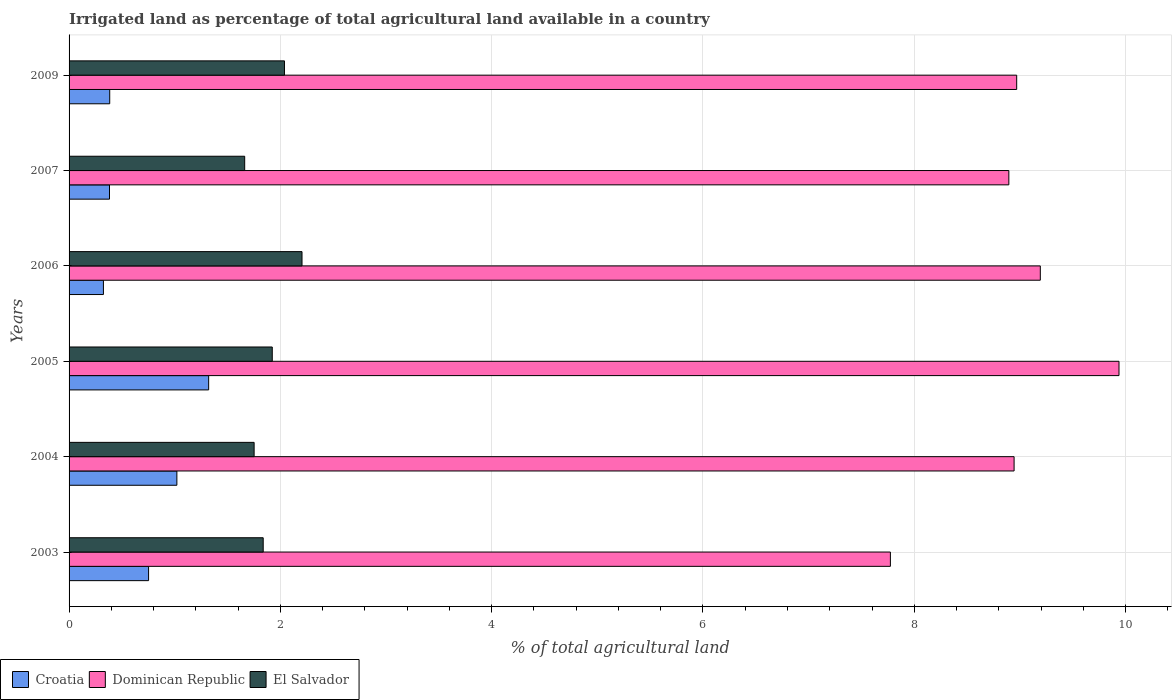How many different coloured bars are there?
Your answer should be very brief. 3. Are the number of bars on each tick of the Y-axis equal?
Provide a short and direct response. Yes. How many bars are there on the 2nd tick from the bottom?
Your answer should be compact. 3. In how many cases, is the number of bars for a given year not equal to the number of legend labels?
Make the answer very short. 0. What is the percentage of irrigated land in Croatia in 2005?
Ensure brevity in your answer.  1.32. Across all years, what is the maximum percentage of irrigated land in El Salvador?
Your answer should be very brief. 2.2. Across all years, what is the minimum percentage of irrigated land in El Salvador?
Keep it short and to the point. 1.66. In which year was the percentage of irrigated land in Dominican Republic maximum?
Make the answer very short. 2005. What is the total percentage of irrigated land in El Salvador in the graph?
Provide a succinct answer. 11.42. What is the difference between the percentage of irrigated land in Dominican Republic in 2005 and that in 2007?
Give a very brief answer. 1.04. What is the difference between the percentage of irrigated land in El Salvador in 2009 and the percentage of irrigated land in Croatia in 2003?
Your answer should be compact. 1.29. What is the average percentage of irrigated land in Dominican Republic per year?
Provide a succinct answer. 8.95. In the year 2006, what is the difference between the percentage of irrigated land in Croatia and percentage of irrigated land in El Salvador?
Keep it short and to the point. -1.88. What is the ratio of the percentage of irrigated land in El Salvador in 2004 to that in 2007?
Keep it short and to the point. 1.05. Is the percentage of irrigated land in Croatia in 2005 less than that in 2006?
Keep it short and to the point. No. Is the difference between the percentage of irrigated land in Croatia in 2003 and 2004 greater than the difference between the percentage of irrigated land in El Salvador in 2003 and 2004?
Your answer should be very brief. No. What is the difference between the highest and the second highest percentage of irrigated land in Dominican Republic?
Your answer should be compact. 0.74. What is the difference between the highest and the lowest percentage of irrigated land in El Salvador?
Your answer should be very brief. 0.54. In how many years, is the percentage of irrigated land in Dominican Republic greater than the average percentage of irrigated land in Dominican Republic taken over all years?
Ensure brevity in your answer.  3. What does the 3rd bar from the top in 2003 represents?
Keep it short and to the point. Croatia. What does the 2nd bar from the bottom in 2009 represents?
Provide a short and direct response. Dominican Republic. Is it the case that in every year, the sum of the percentage of irrigated land in El Salvador and percentage of irrigated land in Croatia is greater than the percentage of irrigated land in Dominican Republic?
Your response must be concise. No. How many bars are there?
Ensure brevity in your answer.  18. Are the values on the major ticks of X-axis written in scientific E-notation?
Your answer should be compact. No. How many legend labels are there?
Provide a succinct answer. 3. How are the legend labels stacked?
Give a very brief answer. Horizontal. What is the title of the graph?
Offer a terse response. Irrigated land as percentage of total agricultural land available in a country. What is the label or title of the X-axis?
Offer a very short reply. % of total agricultural land. What is the label or title of the Y-axis?
Keep it short and to the point. Years. What is the % of total agricultural land of Croatia in 2003?
Provide a short and direct response. 0.75. What is the % of total agricultural land in Dominican Republic in 2003?
Give a very brief answer. 7.77. What is the % of total agricultural land in El Salvador in 2003?
Make the answer very short. 1.84. What is the % of total agricultural land in Croatia in 2004?
Give a very brief answer. 1.02. What is the % of total agricultural land in Dominican Republic in 2004?
Provide a succinct answer. 8.94. What is the % of total agricultural land of El Salvador in 2004?
Ensure brevity in your answer.  1.75. What is the % of total agricultural land of Croatia in 2005?
Your response must be concise. 1.32. What is the % of total agricultural land in Dominican Republic in 2005?
Keep it short and to the point. 9.94. What is the % of total agricultural land of El Salvador in 2005?
Offer a terse response. 1.92. What is the % of total agricultural land of Croatia in 2006?
Make the answer very short. 0.33. What is the % of total agricultural land of Dominican Republic in 2006?
Give a very brief answer. 9.19. What is the % of total agricultural land of El Salvador in 2006?
Your answer should be very brief. 2.2. What is the % of total agricultural land of Croatia in 2007?
Provide a short and direct response. 0.38. What is the % of total agricultural land in Dominican Republic in 2007?
Make the answer very short. 8.9. What is the % of total agricultural land of El Salvador in 2007?
Offer a very short reply. 1.66. What is the % of total agricultural land of Croatia in 2009?
Give a very brief answer. 0.38. What is the % of total agricultural land in Dominican Republic in 2009?
Provide a succinct answer. 8.97. What is the % of total agricultural land of El Salvador in 2009?
Your answer should be compact. 2.04. Across all years, what is the maximum % of total agricultural land in Croatia?
Ensure brevity in your answer.  1.32. Across all years, what is the maximum % of total agricultural land of Dominican Republic?
Provide a succinct answer. 9.94. Across all years, what is the maximum % of total agricultural land of El Salvador?
Give a very brief answer. 2.2. Across all years, what is the minimum % of total agricultural land in Croatia?
Provide a succinct answer. 0.33. Across all years, what is the minimum % of total agricultural land of Dominican Republic?
Provide a short and direct response. 7.77. Across all years, what is the minimum % of total agricultural land of El Salvador?
Ensure brevity in your answer.  1.66. What is the total % of total agricultural land in Croatia in the graph?
Your answer should be very brief. 4.19. What is the total % of total agricultural land in Dominican Republic in the graph?
Provide a short and direct response. 53.72. What is the total % of total agricultural land of El Salvador in the graph?
Your answer should be very brief. 11.42. What is the difference between the % of total agricultural land in Croatia in 2003 and that in 2004?
Give a very brief answer. -0.27. What is the difference between the % of total agricultural land of Dominican Republic in 2003 and that in 2004?
Offer a terse response. -1.17. What is the difference between the % of total agricultural land of El Salvador in 2003 and that in 2004?
Offer a terse response. 0.09. What is the difference between the % of total agricultural land in Croatia in 2003 and that in 2005?
Offer a terse response. -0.57. What is the difference between the % of total agricultural land in Dominican Republic in 2003 and that in 2005?
Provide a short and direct response. -2.16. What is the difference between the % of total agricultural land of El Salvador in 2003 and that in 2005?
Provide a short and direct response. -0.09. What is the difference between the % of total agricultural land of Croatia in 2003 and that in 2006?
Give a very brief answer. 0.43. What is the difference between the % of total agricultural land of Dominican Republic in 2003 and that in 2006?
Provide a short and direct response. -1.42. What is the difference between the % of total agricultural land in El Salvador in 2003 and that in 2006?
Offer a very short reply. -0.37. What is the difference between the % of total agricultural land of Croatia in 2003 and that in 2007?
Your answer should be compact. 0.37. What is the difference between the % of total agricultural land in Dominican Republic in 2003 and that in 2007?
Your response must be concise. -1.12. What is the difference between the % of total agricultural land of El Salvador in 2003 and that in 2007?
Provide a succinct answer. 0.18. What is the difference between the % of total agricultural land of Croatia in 2003 and that in 2009?
Offer a very short reply. 0.37. What is the difference between the % of total agricultural land in Dominican Republic in 2003 and that in 2009?
Make the answer very short. -1.2. What is the difference between the % of total agricultural land in El Salvador in 2003 and that in 2009?
Give a very brief answer. -0.2. What is the difference between the % of total agricultural land of Croatia in 2004 and that in 2005?
Give a very brief answer. -0.3. What is the difference between the % of total agricultural land of Dominican Republic in 2004 and that in 2005?
Your answer should be compact. -0.99. What is the difference between the % of total agricultural land of El Salvador in 2004 and that in 2005?
Make the answer very short. -0.17. What is the difference between the % of total agricultural land of Croatia in 2004 and that in 2006?
Make the answer very short. 0.7. What is the difference between the % of total agricultural land in Dominican Republic in 2004 and that in 2006?
Provide a succinct answer. -0.25. What is the difference between the % of total agricultural land in El Salvador in 2004 and that in 2006?
Provide a short and direct response. -0.45. What is the difference between the % of total agricultural land in Croatia in 2004 and that in 2007?
Offer a very short reply. 0.64. What is the difference between the % of total agricultural land of Dominican Republic in 2004 and that in 2007?
Give a very brief answer. 0.05. What is the difference between the % of total agricultural land of El Salvador in 2004 and that in 2007?
Your answer should be very brief. 0.09. What is the difference between the % of total agricultural land in Croatia in 2004 and that in 2009?
Provide a succinct answer. 0.64. What is the difference between the % of total agricultural land of Dominican Republic in 2004 and that in 2009?
Your answer should be very brief. -0.02. What is the difference between the % of total agricultural land of El Salvador in 2004 and that in 2009?
Give a very brief answer. -0.29. What is the difference between the % of total agricultural land in Croatia in 2005 and that in 2006?
Provide a short and direct response. 1. What is the difference between the % of total agricultural land in Dominican Republic in 2005 and that in 2006?
Your response must be concise. 0.74. What is the difference between the % of total agricultural land in El Salvador in 2005 and that in 2006?
Give a very brief answer. -0.28. What is the difference between the % of total agricultural land of Croatia in 2005 and that in 2007?
Make the answer very short. 0.94. What is the difference between the % of total agricultural land of Dominican Republic in 2005 and that in 2007?
Give a very brief answer. 1.04. What is the difference between the % of total agricultural land of El Salvador in 2005 and that in 2007?
Your answer should be compact. 0.26. What is the difference between the % of total agricultural land of Croatia in 2005 and that in 2009?
Ensure brevity in your answer.  0.94. What is the difference between the % of total agricultural land in Dominican Republic in 2005 and that in 2009?
Offer a terse response. 0.97. What is the difference between the % of total agricultural land of El Salvador in 2005 and that in 2009?
Your answer should be very brief. -0.12. What is the difference between the % of total agricultural land of Croatia in 2006 and that in 2007?
Make the answer very short. -0.06. What is the difference between the % of total agricultural land in Dominican Republic in 2006 and that in 2007?
Your answer should be compact. 0.3. What is the difference between the % of total agricultural land in El Salvador in 2006 and that in 2007?
Your answer should be compact. 0.54. What is the difference between the % of total agricultural land in Croatia in 2006 and that in 2009?
Your response must be concise. -0.06. What is the difference between the % of total agricultural land of Dominican Republic in 2006 and that in 2009?
Keep it short and to the point. 0.22. What is the difference between the % of total agricultural land of El Salvador in 2006 and that in 2009?
Your answer should be very brief. 0.17. What is the difference between the % of total agricultural land in Croatia in 2007 and that in 2009?
Offer a terse response. -0. What is the difference between the % of total agricultural land of Dominican Republic in 2007 and that in 2009?
Your answer should be very brief. -0.07. What is the difference between the % of total agricultural land of El Salvador in 2007 and that in 2009?
Offer a terse response. -0.38. What is the difference between the % of total agricultural land in Croatia in 2003 and the % of total agricultural land in Dominican Republic in 2004?
Offer a terse response. -8.19. What is the difference between the % of total agricultural land of Croatia in 2003 and the % of total agricultural land of El Salvador in 2004?
Keep it short and to the point. -1. What is the difference between the % of total agricultural land of Dominican Republic in 2003 and the % of total agricultural land of El Salvador in 2004?
Offer a terse response. 6.02. What is the difference between the % of total agricultural land of Croatia in 2003 and the % of total agricultural land of Dominican Republic in 2005?
Your answer should be compact. -9.19. What is the difference between the % of total agricultural land of Croatia in 2003 and the % of total agricultural land of El Salvador in 2005?
Keep it short and to the point. -1.17. What is the difference between the % of total agricultural land of Dominican Republic in 2003 and the % of total agricultural land of El Salvador in 2005?
Give a very brief answer. 5.85. What is the difference between the % of total agricultural land of Croatia in 2003 and the % of total agricultural land of Dominican Republic in 2006?
Ensure brevity in your answer.  -8.44. What is the difference between the % of total agricultural land in Croatia in 2003 and the % of total agricultural land in El Salvador in 2006?
Your answer should be very brief. -1.45. What is the difference between the % of total agricultural land of Dominican Republic in 2003 and the % of total agricultural land of El Salvador in 2006?
Ensure brevity in your answer.  5.57. What is the difference between the % of total agricultural land in Croatia in 2003 and the % of total agricultural land in Dominican Republic in 2007?
Keep it short and to the point. -8.14. What is the difference between the % of total agricultural land of Croatia in 2003 and the % of total agricultural land of El Salvador in 2007?
Make the answer very short. -0.91. What is the difference between the % of total agricultural land in Dominican Republic in 2003 and the % of total agricultural land in El Salvador in 2007?
Make the answer very short. 6.11. What is the difference between the % of total agricultural land in Croatia in 2003 and the % of total agricultural land in Dominican Republic in 2009?
Offer a terse response. -8.22. What is the difference between the % of total agricultural land of Croatia in 2003 and the % of total agricultural land of El Salvador in 2009?
Your answer should be compact. -1.29. What is the difference between the % of total agricultural land of Dominican Republic in 2003 and the % of total agricultural land of El Salvador in 2009?
Your response must be concise. 5.74. What is the difference between the % of total agricultural land in Croatia in 2004 and the % of total agricultural land in Dominican Republic in 2005?
Your response must be concise. -8.92. What is the difference between the % of total agricultural land of Croatia in 2004 and the % of total agricultural land of El Salvador in 2005?
Offer a terse response. -0.9. What is the difference between the % of total agricultural land of Dominican Republic in 2004 and the % of total agricultural land of El Salvador in 2005?
Provide a short and direct response. 7.02. What is the difference between the % of total agricultural land in Croatia in 2004 and the % of total agricultural land in Dominican Republic in 2006?
Your response must be concise. -8.17. What is the difference between the % of total agricultural land in Croatia in 2004 and the % of total agricultural land in El Salvador in 2006?
Your answer should be compact. -1.18. What is the difference between the % of total agricultural land in Dominican Republic in 2004 and the % of total agricultural land in El Salvador in 2006?
Your answer should be very brief. 6.74. What is the difference between the % of total agricultural land in Croatia in 2004 and the % of total agricultural land in Dominican Republic in 2007?
Keep it short and to the point. -7.87. What is the difference between the % of total agricultural land of Croatia in 2004 and the % of total agricultural land of El Salvador in 2007?
Ensure brevity in your answer.  -0.64. What is the difference between the % of total agricultural land of Dominican Republic in 2004 and the % of total agricultural land of El Salvador in 2007?
Provide a short and direct response. 7.28. What is the difference between the % of total agricultural land of Croatia in 2004 and the % of total agricultural land of Dominican Republic in 2009?
Provide a succinct answer. -7.95. What is the difference between the % of total agricultural land in Croatia in 2004 and the % of total agricultural land in El Salvador in 2009?
Make the answer very short. -1.02. What is the difference between the % of total agricultural land in Dominican Republic in 2004 and the % of total agricultural land in El Salvador in 2009?
Provide a succinct answer. 6.91. What is the difference between the % of total agricultural land of Croatia in 2005 and the % of total agricultural land of Dominican Republic in 2006?
Offer a very short reply. -7.87. What is the difference between the % of total agricultural land in Croatia in 2005 and the % of total agricultural land in El Salvador in 2006?
Offer a terse response. -0.88. What is the difference between the % of total agricultural land of Dominican Republic in 2005 and the % of total agricultural land of El Salvador in 2006?
Provide a succinct answer. 7.73. What is the difference between the % of total agricultural land in Croatia in 2005 and the % of total agricultural land in Dominican Republic in 2007?
Your answer should be very brief. -7.57. What is the difference between the % of total agricultural land of Croatia in 2005 and the % of total agricultural land of El Salvador in 2007?
Your response must be concise. -0.34. What is the difference between the % of total agricultural land of Dominican Republic in 2005 and the % of total agricultural land of El Salvador in 2007?
Your answer should be compact. 8.28. What is the difference between the % of total agricultural land of Croatia in 2005 and the % of total agricultural land of Dominican Republic in 2009?
Ensure brevity in your answer.  -7.65. What is the difference between the % of total agricultural land of Croatia in 2005 and the % of total agricultural land of El Salvador in 2009?
Offer a terse response. -0.72. What is the difference between the % of total agricultural land in Dominican Republic in 2005 and the % of total agricultural land in El Salvador in 2009?
Give a very brief answer. 7.9. What is the difference between the % of total agricultural land of Croatia in 2006 and the % of total agricultural land of Dominican Republic in 2007?
Provide a succinct answer. -8.57. What is the difference between the % of total agricultural land in Croatia in 2006 and the % of total agricultural land in El Salvador in 2007?
Keep it short and to the point. -1.34. What is the difference between the % of total agricultural land of Dominican Republic in 2006 and the % of total agricultural land of El Salvador in 2007?
Keep it short and to the point. 7.53. What is the difference between the % of total agricultural land in Croatia in 2006 and the % of total agricultural land in Dominican Republic in 2009?
Keep it short and to the point. -8.64. What is the difference between the % of total agricultural land in Croatia in 2006 and the % of total agricultural land in El Salvador in 2009?
Ensure brevity in your answer.  -1.71. What is the difference between the % of total agricultural land of Dominican Republic in 2006 and the % of total agricultural land of El Salvador in 2009?
Make the answer very short. 7.15. What is the difference between the % of total agricultural land of Croatia in 2007 and the % of total agricultural land of Dominican Republic in 2009?
Ensure brevity in your answer.  -8.59. What is the difference between the % of total agricultural land in Croatia in 2007 and the % of total agricultural land in El Salvador in 2009?
Provide a short and direct response. -1.66. What is the difference between the % of total agricultural land in Dominican Republic in 2007 and the % of total agricultural land in El Salvador in 2009?
Your response must be concise. 6.86. What is the average % of total agricultural land in Croatia per year?
Provide a succinct answer. 0.7. What is the average % of total agricultural land in Dominican Republic per year?
Offer a very short reply. 8.95. What is the average % of total agricultural land in El Salvador per year?
Offer a very short reply. 1.9. In the year 2003, what is the difference between the % of total agricultural land of Croatia and % of total agricultural land of Dominican Republic?
Ensure brevity in your answer.  -7.02. In the year 2003, what is the difference between the % of total agricultural land in Croatia and % of total agricultural land in El Salvador?
Ensure brevity in your answer.  -1.08. In the year 2003, what is the difference between the % of total agricultural land in Dominican Republic and % of total agricultural land in El Salvador?
Offer a very short reply. 5.94. In the year 2004, what is the difference between the % of total agricultural land of Croatia and % of total agricultural land of Dominican Republic?
Your answer should be compact. -7.92. In the year 2004, what is the difference between the % of total agricultural land in Croatia and % of total agricultural land in El Salvador?
Give a very brief answer. -0.73. In the year 2004, what is the difference between the % of total agricultural land of Dominican Republic and % of total agricultural land of El Salvador?
Your answer should be compact. 7.19. In the year 2005, what is the difference between the % of total agricultural land of Croatia and % of total agricultural land of Dominican Republic?
Ensure brevity in your answer.  -8.62. In the year 2005, what is the difference between the % of total agricultural land of Croatia and % of total agricultural land of El Salvador?
Provide a succinct answer. -0.6. In the year 2005, what is the difference between the % of total agricultural land in Dominican Republic and % of total agricultural land in El Salvador?
Your answer should be very brief. 8.01. In the year 2006, what is the difference between the % of total agricultural land of Croatia and % of total agricultural land of Dominican Republic?
Your answer should be very brief. -8.87. In the year 2006, what is the difference between the % of total agricultural land of Croatia and % of total agricultural land of El Salvador?
Offer a very short reply. -1.88. In the year 2006, what is the difference between the % of total agricultural land of Dominican Republic and % of total agricultural land of El Salvador?
Your answer should be very brief. 6.99. In the year 2007, what is the difference between the % of total agricultural land of Croatia and % of total agricultural land of Dominican Republic?
Your answer should be compact. -8.51. In the year 2007, what is the difference between the % of total agricultural land in Croatia and % of total agricultural land in El Salvador?
Your answer should be compact. -1.28. In the year 2007, what is the difference between the % of total agricultural land of Dominican Republic and % of total agricultural land of El Salvador?
Your response must be concise. 7.23. In the year 2009, what is the difference between the % of total agricultural land of Croatia and % of total agricultural land of Dominican Republic?
Keep it short and to the point. -8.58. In the year 2009, what is the difference between the % of total agricultural land in Croatia and % of total agricultural land in El Salvador?
Give a very brief answer. -1.65. In the year 2009, what is the difference between the % of total agricultural land in Dominican Republic and % of total agricultural land in El Salvador?
Provide a succinct answer. 6.93. What is the ratio of the % of total agricultural land of Croatia in 2003 to that in 2004?
Keep it short and to the point. 0.74. What is the ratio of the % of total agricultural land of Dominican Republic in 2003 to that in 2004?
Your response must be concise. 0.87. What is the ratio of the % of total agricultural land in El Salvador in 2003 to that in 2004?
Provide a succinct answer. 1.05. What is the ratio of the % of total agricultural land of Croatia in 2003 to that in 2005?
Your answer should be compact. 0.57. What is the ratio of the % of total agricultural land of Dominican Republic in 2003 to that in 2005?
Offer a terse response. 0.78. What is the ratio of the % of total agricultural land in El Salvador in 2003 to that in 2005?
Your answer should be compact. 0.96. What is the ratio of the % of total agricultural land in Croatia in 2003 to that in 2006?
Give a very brief answer. 2.31. What is the ratio of the % of total agricultural land in Dominican Republic in 2003 to that in 2006?
Your response must be concise. 0.85. What is the ratio of the % of total agricultural land in El Salvador in 2003 to that in 2006?
Give a very brief answer. 0.83. What is the ratio of the % of total agricultural land in Croatia in 2003 to that in 2007?
Make the answer very short. 1.97. What is the ratio of the % of total agricultural land in Dominican Republic in 2003 to that in 2007?
Your response must be concise. 0.87. What is the ratio of the % of total agricultural land in El Salvador in 2003 to that in 2007?
Offer a terse response. 1.11. What is the ratio of the % of total agricultural land of Croatia in 2003 to that in 2009?
Ensure brevity in your answer.  1.96. What is the ratio of the % of total agricultural land of Dominican Republic in 2003 to that in 2009?
Provide a short and direct response. 0.87. What is the ratio of the % of total agricultural land of El Salvador in 2003 to that in 2009?
Your response must be concise. 0.9. What is the ratio of the % of total agricultural land in Croatia in 2004 to that in 2005?
Make the answer very short. 0.77. What is the ratio of the % of total agricultural land of Dominican Republic in 2004 to that in 2005?
Your response must be concise. 0.9. What is the ratio of the % of total agricultural land in El Salvador in 2004 to that in 2005?
Offer a very short reply. 0.91. What is the ratio of the % of total agricultural land of Croatia in 2004 to that in 2006?
Make the answer very short. 3.14. What is the ratio of the % of total agricultural land of Dominican Republic in 2004 to that in 2006?
Your answer should be compact. 0.97. What is the ratio of the % of total agricultural land of El Salvador in 2004 to that in 2006?
Your response must be concise. 0.79. What is the ratio of the % of total agricultural land in Croatia in 2004 to that in 2007?
Keep it short and to the point. 2.67. What is the ratio of the % of total agricultural land in Dominican Republic in 2004 to that in 2007?
Give a very brief answer. 1.01. What is the ratio of the % of total agricultural land in El Salvador in 2004 to that in 2007?
Your answer should be very brief. 1.05. What is the ratio of the % of total agricultural land in Croatia in 2004 to that in 2009?
Provide a succinct answer. 2.65. What is the ratio of the % of total agricultural land in Dominican Republic in 2004 to that in 2009?
Keep it short and to the point. 1. What is the ratio of the % of total agricultural land in El Salvador in 2004 to that in 2009?
Ensure brevity in your answer.  0.86. What is the ratio of the % of total agricultural land in Croatia in 2005 to that in 2006?
Make the answer very short. 4.06. What is the ratio of the % of total agricultural land of Dominican Republic in 2005 to that in 2006?
Your answer should be compact. 1.08. What is the ratio of the % of total agricultural land in El Salvador in 2005 to that in 2006?
Make the answer very short. 0.87. What is the ratio of the % of total agricultural land in Croatia in 2005 to that in 2007?
Make the answer very short. 3.45. What is the ratio of the % of total agricultural land in Dominican Republic in 2005 to that in 2007?
Your response must be concise. 1.12. What is the ratio of the % of total agricultural land in El Salvador in 2005 to that in 2007?
Offer a terse response. 1.16. What is the ratio of the % of total agricultural land in Croatia in 2005 to that in 2009?
Offer a very short reply. 3.43. What is the ratio of the % of total agricultural land in Dominican Republic in 2005 to that in 2009?
Your response must be concise. 1.11. What is the ratio of the % of total agricultural land of El Salvador in 2005 to that in 2009?
Your answer should be compact. 0.94. What is the ratio of the % of total agricultural land in Croatia in 2006 to that in 2007?
Your answer should be very brief. 0.85. What is the ratio of the % of total agricultural land in Dominican Republic in 2006 to that in 2007?
Provide a succinct answer. 1.03. What is the ratio of the % of total agricultural land of El Salvador in 2006 to that in 2007?
Keep it short and to the point. 1.33. What is the ratio of the % of total agricultural land in Croatia in 2006 to that in 2009?
Provide a short and direct response. 0.85. What is the ratio of the % of total agricultural land in Dominican Republic in 2006 to that in 2009?
Ensure brevity in your answer.  1.02. What is the ratio of the % of total agricultural land of El Salvador in 2006 to that in 2009?
Provide a succinct answer. 1.08. What is the ratio of the % of total agricultural land of Croatia in 2007 to that in 2009?
Your response must be concise. 0.99. What is the ratio of the % of total agricultural land of El Salvador in 2007 to that in 2009?
Your response must be concise. 0.82. What is the difference between the highest and the second highest % of total agricultural land of Croatia?
Provide a succinct answer. 0.3. What is the difference between the highest and the second highest % of total agricultural land of Dominican Republic?
Provide a short and direct response. 0.74. What is the difference between the highest and the second highest % of total agricultural land in El Salvador?
Offer a very short reply. 0.17. What is the difference between the highest and the lowest % of total agricultural land of Dominican Republic?
Your answer should be very brief. 2.16. What is the difference between the highest and the lowest % of total agricultural land of El Salvador?
Your answer should be compact. 0.54. 